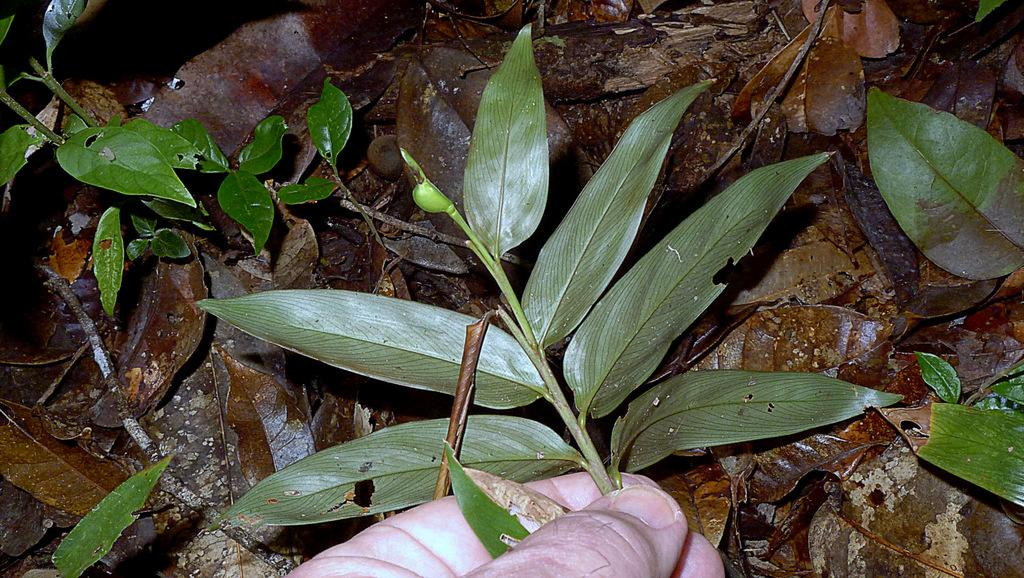Who or what is the main subject in the image? There is a person in the image. What is the person holding in the image? The person is holding a stem of leaves. What else can be seen in the background of the image? There are leaves in the background of the image. What type of soap is the person using to clean the frame in the image? There is no soap, frame, or cleaning activity depicted in the image. 